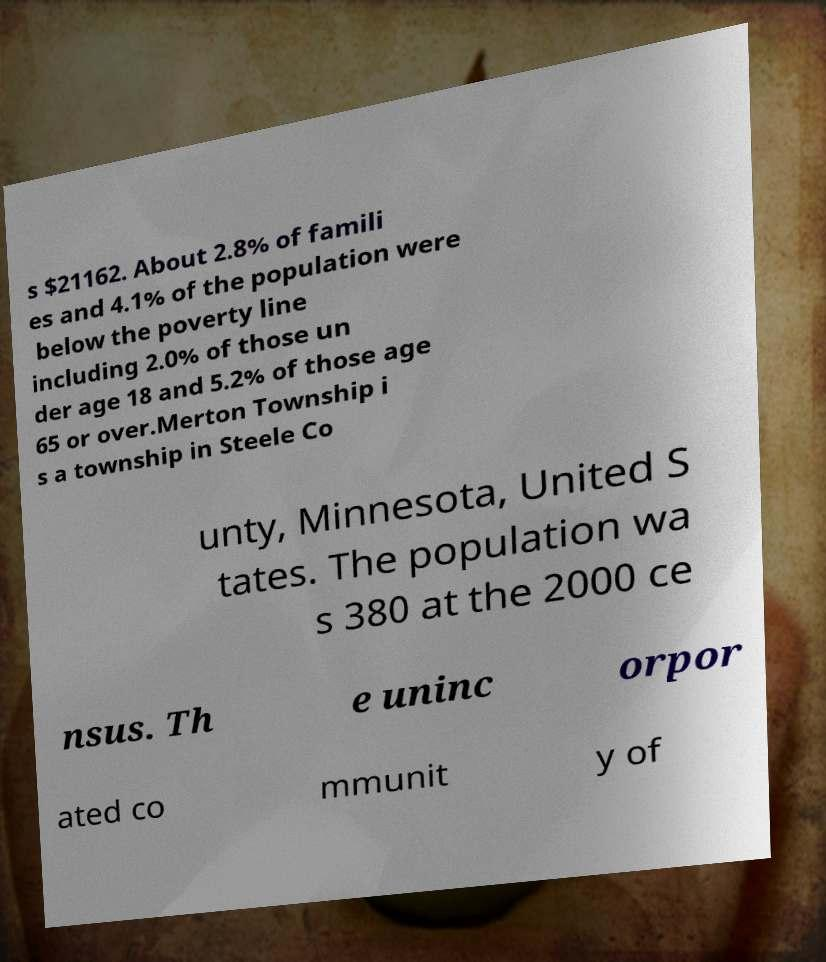What messages or text are displayed in this image? I need them in a readable, typed format. s $21162. About 2.8% of famili es and 4.1% of the population were below the poverty line including 2.0% of those un der age 18 and 5.2% of those age 65 or over.Merton Township i s a township in Steele Co unty, Minnesota, United S tates. The population wa s 380 at the 2000 ce nsus. Th e uninc orpor ated co mmunit y of 